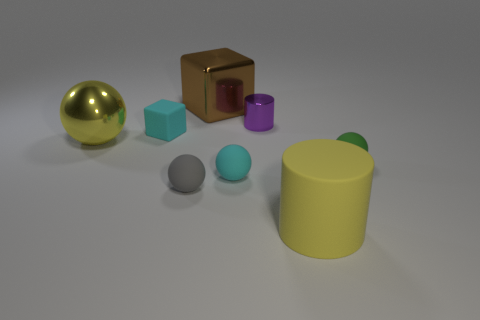Subtract all yellow balls. How many balls are left? 3 Subtract all cyan balls. How many balls are left? 3 Add 2 shiny objects. How many objects exist? 10 Subtract all brown spheres. Subtract all yellow cylinders. How many spheres are left? 4 Subtract all cylinders. How many objects are left? 6 Add 5 cubes. How many cubes exist? 7 Subtract 0 cyan cylinders. How many objects are left? 8 Subtract all small green cylinders. Subtract all tiny shiny cylinders. How many objects are left? 7 Add 1 small cyan matte spheres. How many small cyan matte spheres are left? 2 